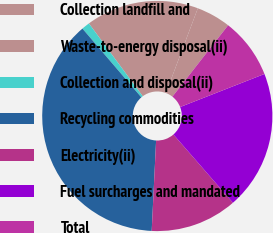Convert chart. <chart><loc_0><loc_0><loc_500><loc_500><pie_chart><fcel>Collection landfill and<fcel>Waste-to-energy disposal(ii)<fcel>Collection and disposal(ii)<fcel>Recycling commodities<fcel>Electricity(ii)<fcel>Fuel surcharges and mandated<fcel>Total<nl><fcel>4.82%<fcel>15.86%<fcel>1.14%<fcel>37.95%<fcel>12.18%<fcel>19.54%<fcel>8.5%<nl></chart> 